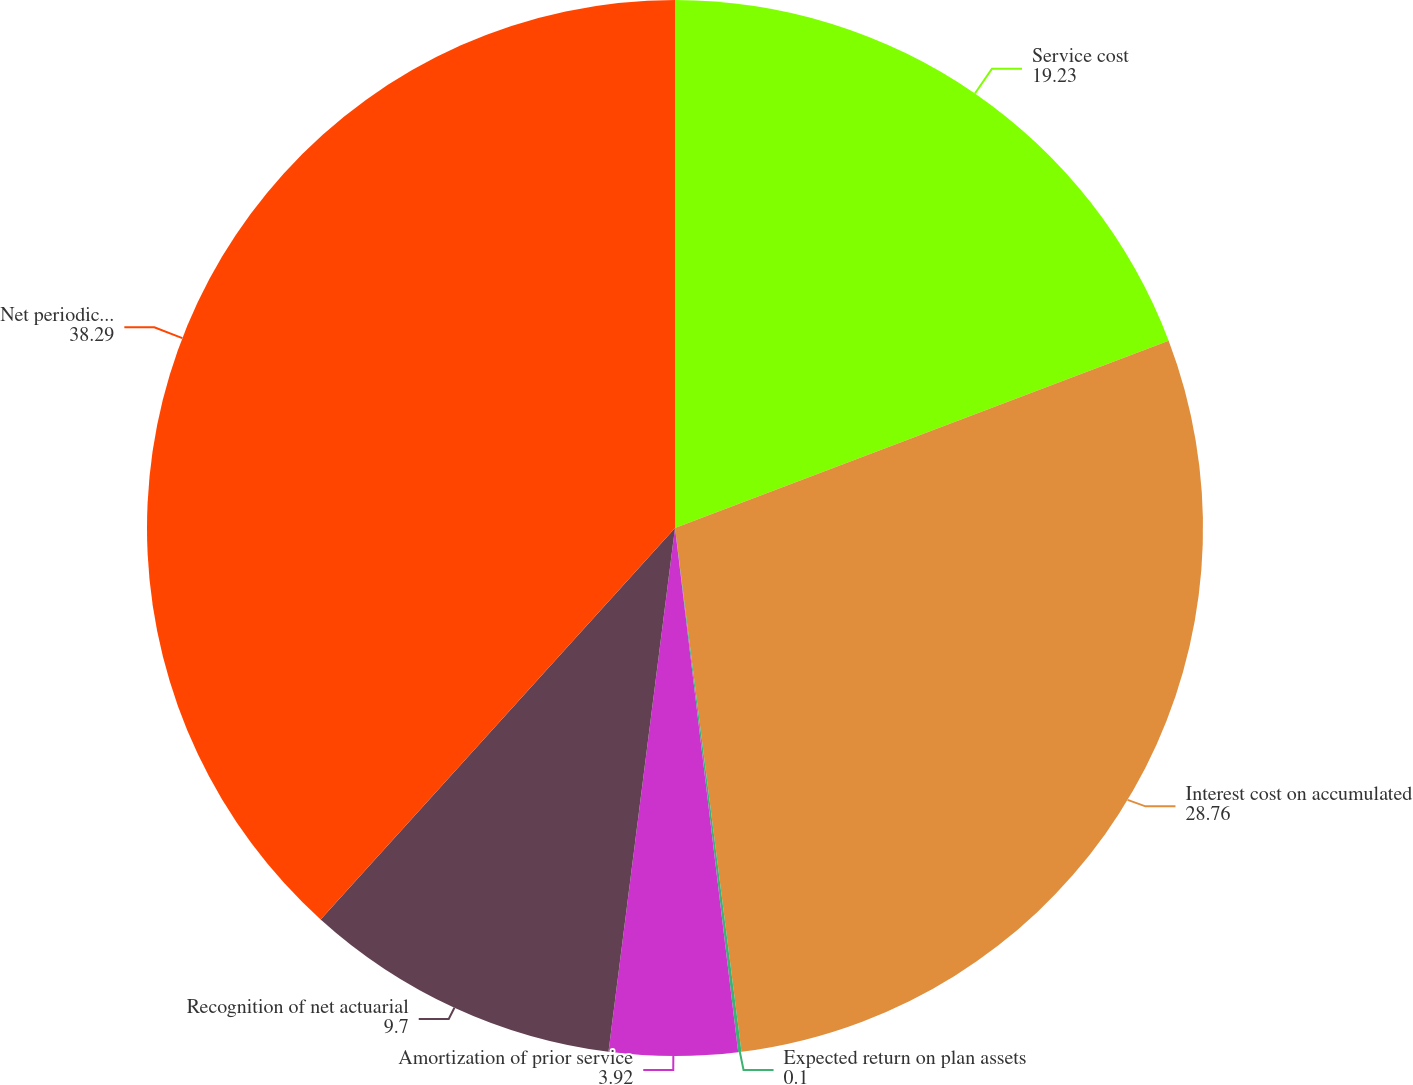<chart> <loc_0><loc_0><loc_500><loc_500><pie_chart><fcel>Service cost<fcel>Interest cost on accumulated<fcel>Expected return on plan assets<fcel>Amortization of prior service<fcel>Recognition of net actuarial<fcel>Net periodic postretirement<nl><fcel>19.23%<fcel>28.76%<fcel>0.1%<fcel>3.92%<fcel>9.7%<fcel>38.29%<nl></chart> 